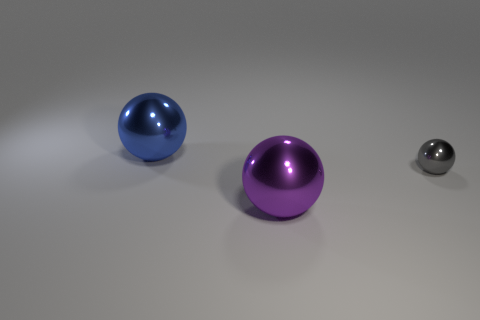There is a metal object that is both right of the large blue shiny object and to the left of the small gray ball; how big is it?
Make the answer very short. Large. How big is the sphere on the left side of the large thing in front of the metallic thing that is behind the gray ball?
Your answer should be compact. Large. There is a metal thing that is in front of the big blue ball and to the left of the tiny shiny sphere; what shape is it?
Provide a succinct answer. Sphere. How many blocks are either big blue objects or tiny gray things?
Give a very brief answer. 0. Do the tiny thing and the large blue object have the same shape?
Your answer should be compact. Yes. What is the size of the shiny sphere that is in front of the small thing?
Offer a very short reply. Large. There is a thing that is behind the gray thing; is it the same size as the tiny ball?
Give a very brief answer. No. What is the color of the small metallic ball?
Your response must be concise. Gray. There is a big thing in front of the object left of the purple thing; what is its color?
Ensure brevity in your answer.  Purple. Are there any other objects that have the same material as the purple thing?
Ensure brevity in your answer.  Yes. 